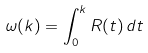Convert formula to latex. <formula><loc_0><loc_0><loc_500><loc_500>\omega ( k ) = \int _ { 0 } ^ { k } R ( t ) \, d t</formula> 